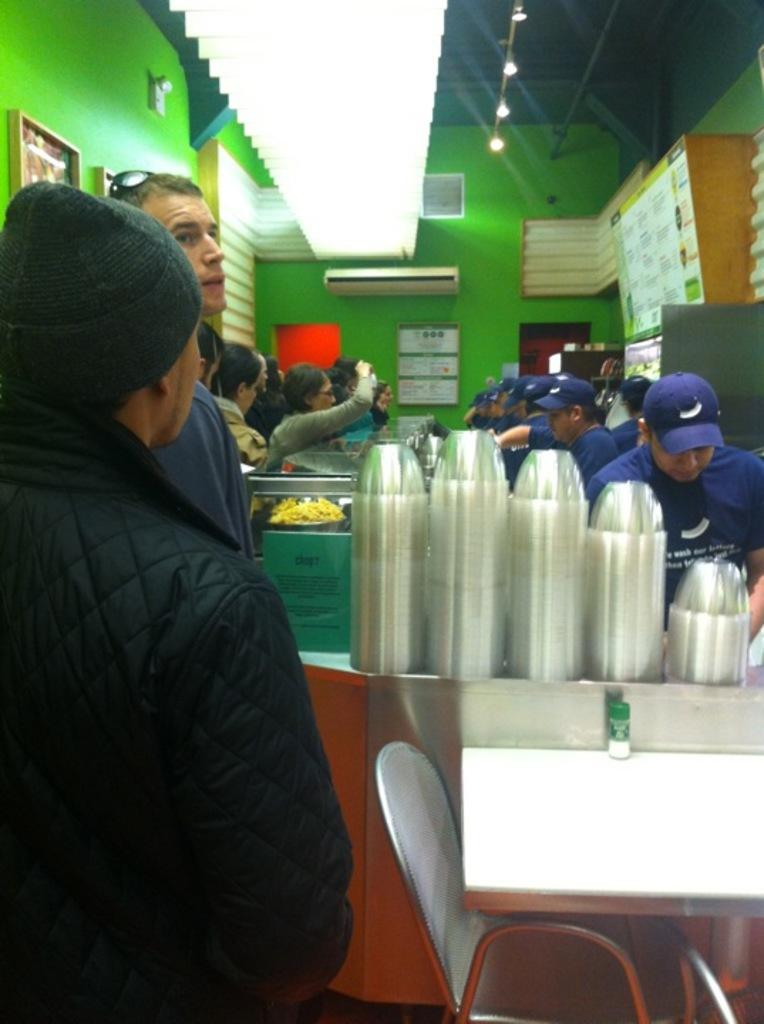How many people are in the image? There are persons in the image, but the exact number cannot be determined from the provided facts. What is on the table in the image? There are cups on the table in the image. What type of furniture is present in the image? There is a chair in the image. What can be seen in the background of the image? There is a wall and light in the background of the image. What type of store is visible in the image? There is no store present in the image. What is being served for lunch in the image? The provided facts do not mention any food or meal being served, so it cannot be determined from the image. 